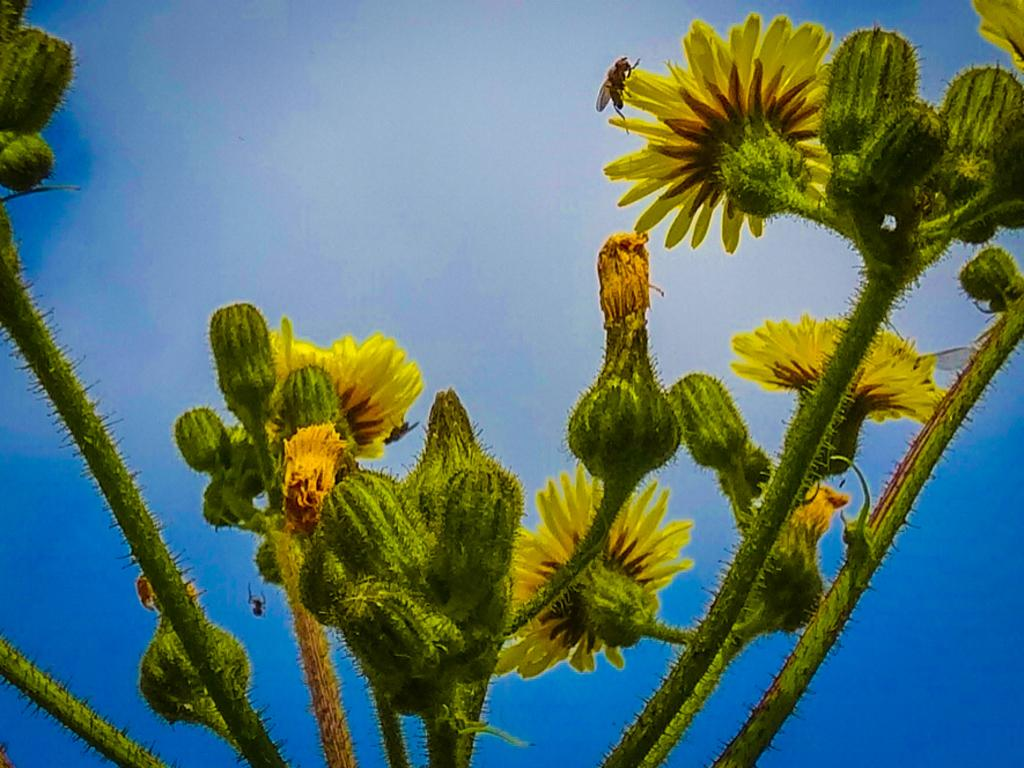What type of plant is depicted in the image? There are green stems with yellow flowers and buds in the image. Can you describe any additional details about the plant? There is a fly on one of the flowers. What color is the background of the image? The background of the image is blue. What type of breakfast is being served on the dock in the image? There is no dock or breakfast present in the image; it features a plant with green stems and yellow flowers, and a fly on one of the flowers. How much salt is sprinkled on the breakfast in the image? There is no breakfast or salt present in the image. 